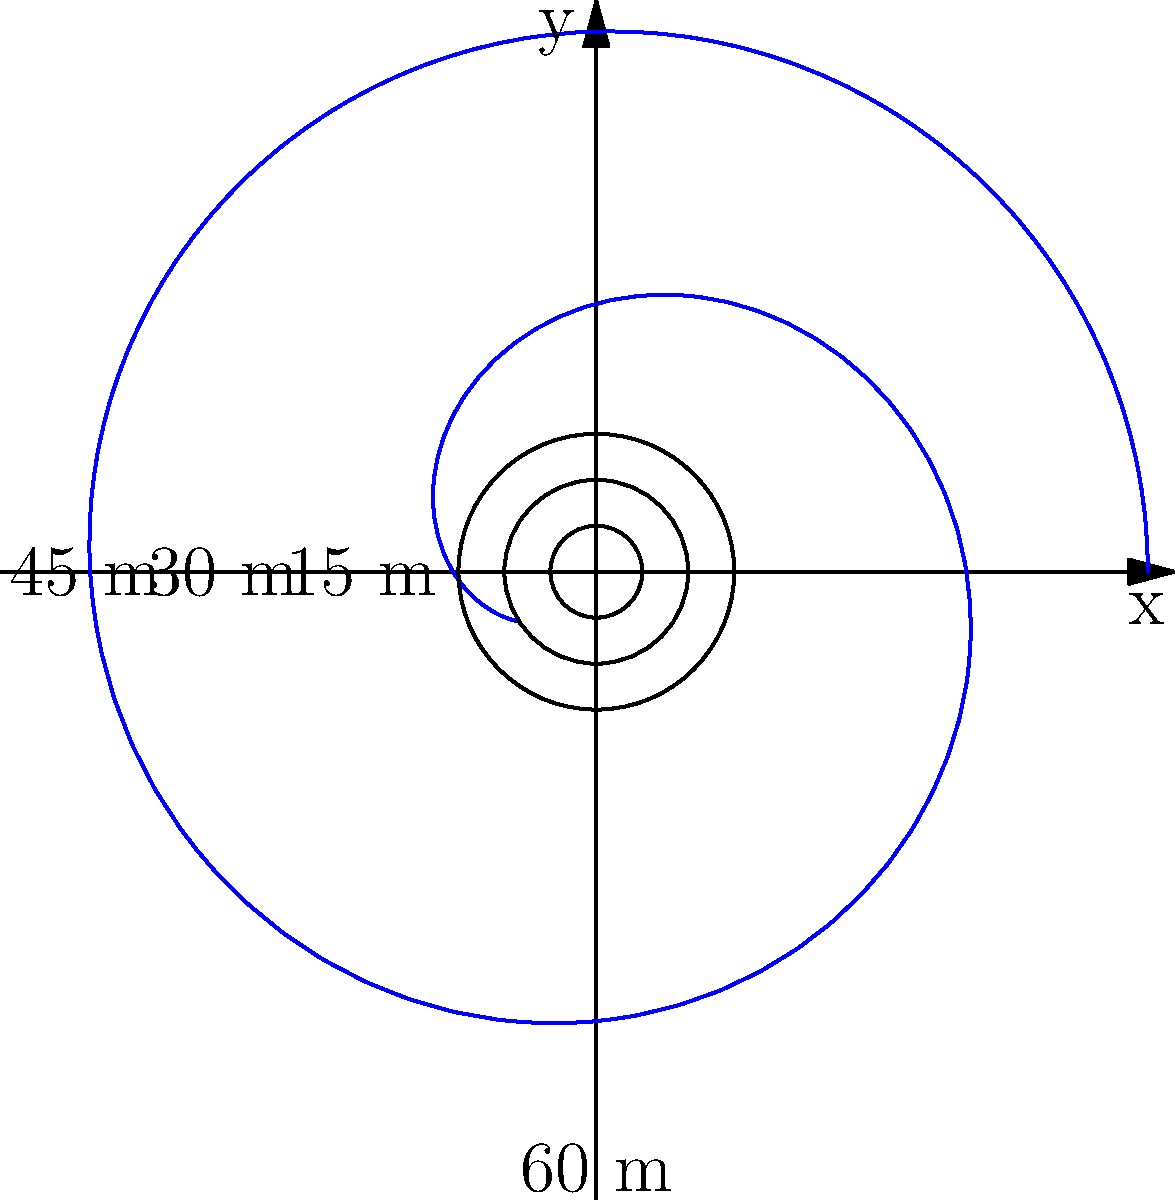As a former UCLA Bruins softball player, you're analyzing the trajectory of a rising fastball. The pitch's path in polar coordinates is given by $r(\theta) = 60 - 0.5\theta^2$, where $r$ is in meters and $\theta$ is in radians. What is the maximum distance (in meters) the ball travels from the pitcher before it starts to drop? To find the maximum distance the ball travels, we need to follow these steps:

1) The maximum distance occurs when $\frac{dr}{d\theta} = 0$.

2) Let's find $\frac{dr}{d\theta}$:
   $\frac{dr}{d\theta} = -0.5 \cdot 2\theta = -\theta$

3) Set this equal to zero:
   $-\theta = 0$
   $\theta = 0$

4) This means the maximum distance occurs when $\theta = 0$.

5) To find the maximum distance, we substitute $\theta = 0$ into the original equation:
   $r(0) = 60 - 0.5(0)^2 = 60$

Therefore, the maximum distance the ball travels from the pitcher is 60 meters.
Answer: 60 meters 